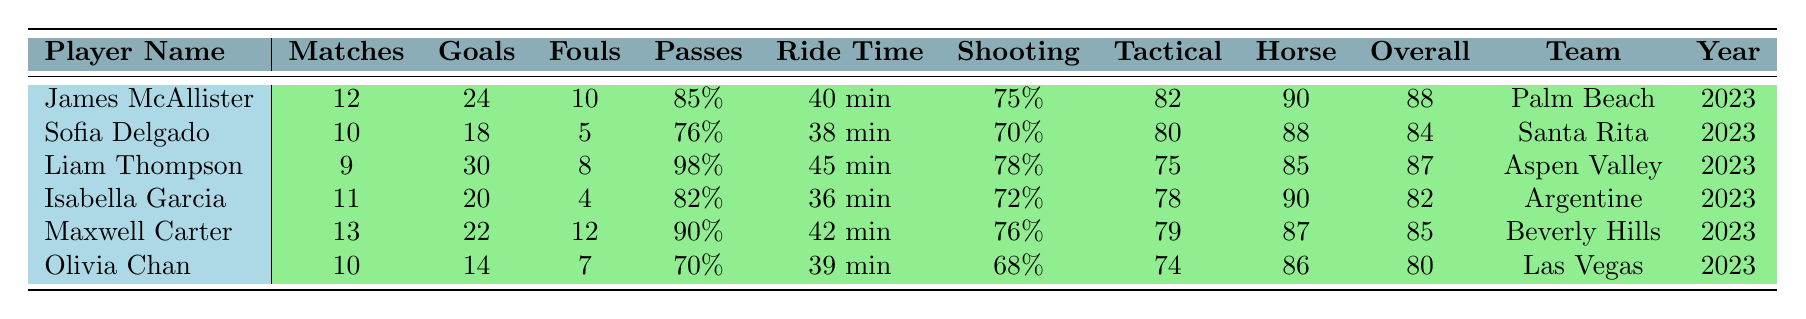What is the highest number of goals scored by a player in 2023? Referring to the table, Liam Thompson scored the highest with 30 goals in 2023.
Answer: 30 Which player had the lowest number of fouls committed? The player with the lowest number of fouls is Isabella Garcia, who committed only 4 fouls.
Answer: 4 What team did Olivia Chan play for in 2023? According to the table, Olivia Chan played for the Las Vegas Polo Club in 2023.
Answer: Las Vegas Polo Club What is the average shooting accuracy among all players? The shooting accuracies of the players are: 75, 70, 78, 72, 76, 68. Calculating the average: (75 + 70 + 78 + 72 + 76 + 68) / 6 = 72.5.
Answer: 72.5 Did James McAllister have more successful passes than Maxwell Carter? James McAllister had 85 successful passes, while Maxwell Carter had 90 successful passes. Therefore, the answer is no.
Answer: No Which player has the highest overall skill rating, and what is that rating? The highest overall skill rating is held by James McAllister with a rating of 88.
Answer: 88 What is the total number of matches played by all players combined? The total matches played are: 12 + 10 + 9 + 11 + 13 + 10 = 65.
Answer: 65 Calculate the difference in average ride time between the player with the highest average and the player with the lowest average. James McAllister had an average ride time of 40 minutes, and Olivia Chan had an average ride time of 39 minutes. The difference in average ride time is 40 - 39 = 1 minute.
Answer: 1 minute Which player had a shooting accuracy above 75% and also scored more than 20 goals? Liam Thompson had a shooting accuracy of 78% and scored 30 goals, which meets the criteria.
Answer: Liam Thompson Is there any player from the Santa Rita Polo Club with an overall skill rating below 85? Sofia Delgado from Santa Rita Polo Club has an overall skill rating of 84, which is below 85. Hence, the answer is yes.
Answer: Yes 